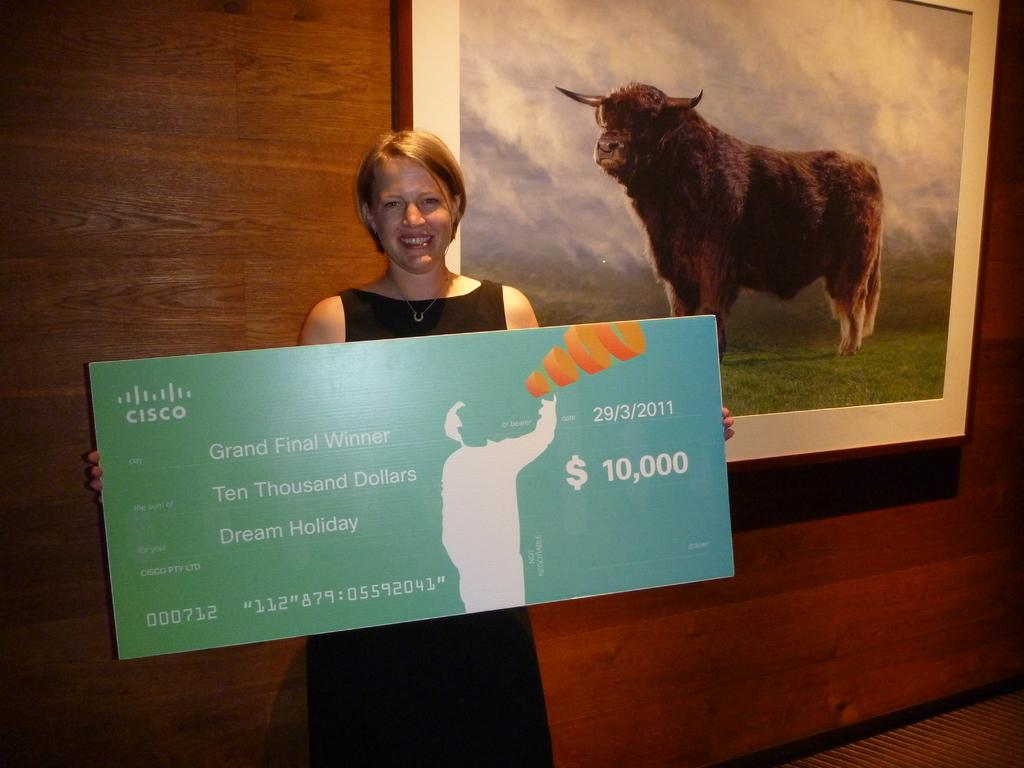What is the woman holding in the image? There is a woman holding a board in the image. What can be seen on the wall in the image? There is a photo frame on the wall in the image. What is depicted in the photo frame? The photo frame contains a picture of a sheep. What type of food is the woman eating in the image? There is no food present in the image; the woman is holding a board. Can you tell me how many soldiers are in the army depicted in the image? There is no army or soldiers depicted in the image; it features a woman holding a board and a photo frame with a picture of a sheep. 